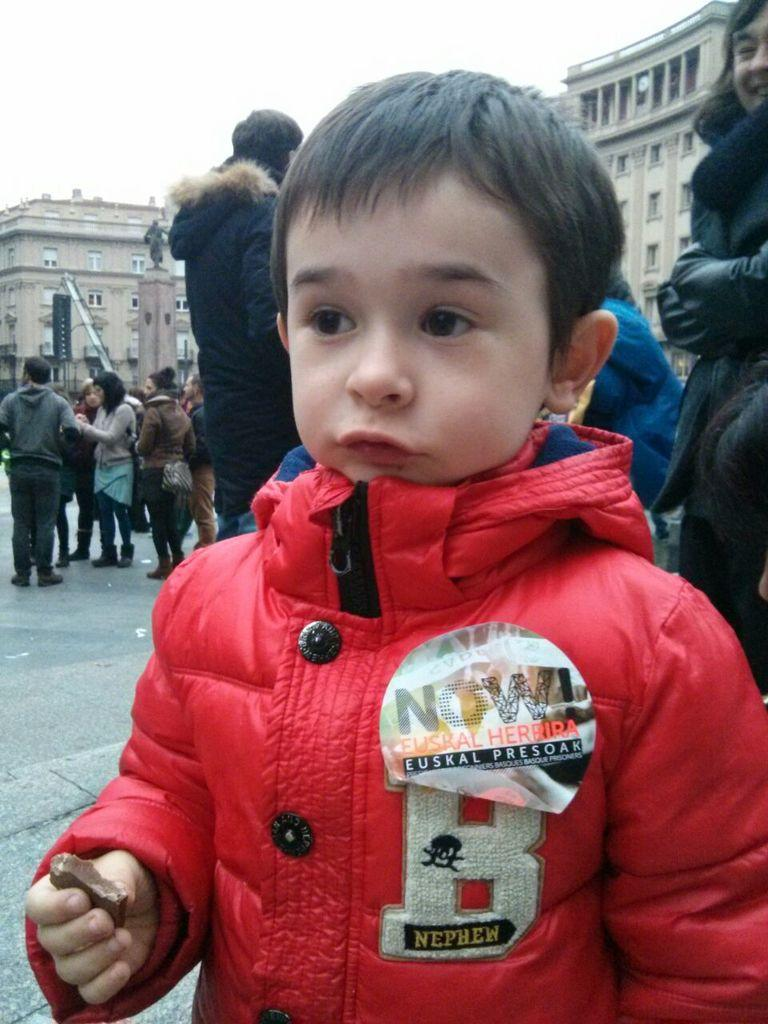What can be seen in the image? There is a group of people in the image, along with buildings, windows, and the sky. Can you describe the group of people? Yes, there is a boy standing in the front of the group, and he is wearing a red color jacket. What else can be seen in the image besides the group of people? There are buildings and windows visible in the image. What is visible at the top of the image? The sky is visible at the top of the image. What type of company is the boy working for in the image? There is no indication in the image that the boy is working for a company. Can you tell me how many yaks are present in the image? There are no yaks present in the image. 